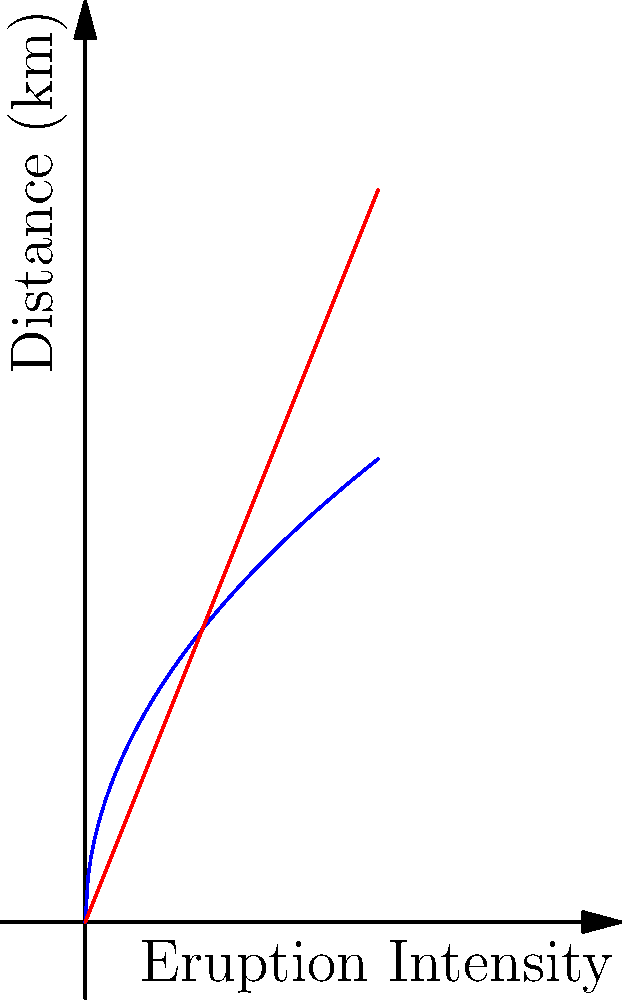As the mayor, you need to determine the safe evacuation radius for your town based on the nearby volcano's height and eruption intensity. The evacuation radius (in km) is calculated as $5\sqrt{I}$, where $I$ is the eruption intensity on a scale of 0 to 10. The volcano's height is 7.5 km. If the eruption intensity is 9, what is the difference between the evacuation radius and the volcano's height? To solve this problem, we'll follow these steps:

1. Calculate the evacuation radius:
   The formula for the evacuation radius is $5\sqrt{I}$, where $I$ is the eruption intensity.
   Given intensity $I = 9$
   Evacuation radius $= 5\sqrt{9} = 5 \times 3 = 15$ km

2. Note the volcano's height:
   The volcano's height is given as 7.5 km

3. Calculate the difference:
   Difference = Evacuation radius - Volcano height
   $= 15 \text{ km} - 7.5 \text{ km} = 7.5 \text{ km}$

Therefore, the difference between the evacuation radius and the volcano's height is 7.5 km.
Answer: 7.5 km 